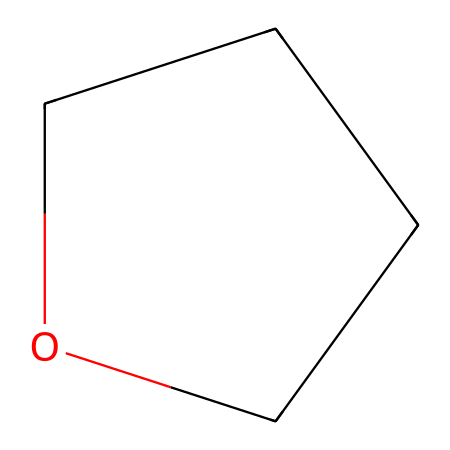What is the name of this chemical? The SMILES representation provided indicates the structure contains a five-membered ring including oxygen, which is characteristic of tetrahydrofuran (THF).
Answer: tetrahydrofuran How many carbons are in the structure? The SMILES notation shows two carbon atoms outside the ring and two within the ring, giving a total of four carbon atoms.
Answer: 4 What is the functional group present in this molecule? The molecule includes an ether group due to the presence of an oxygen atom bonded to two carbons, fulfilling the definition of ethers.
Answer: ether How many hydrogen atoms are connected to the carbon atoms in this molecule? Each carbon in tetrahydrofuran is bonded adequately to hydrogen atoms to satisfy the tetravalency of carbon, leading to a total of eight hydrogen atoms.
Answer: 8 What is the molecular formula of tetrahydrofuran? By counting the atoms represented in the SMILES, we deduce that there are four carbon atoms, eight hydrogen atoms, and one oxygen atom, leading to the formula C4H8O.
Answer: C4H8O What type of solvent is tetrahydrofuran typically used as? Tetrahydrofuran is commonly used as a solvent in pharmaceutical manufacturing due to its ability to dissolve a wide range of polar and nonpolar compounds.
Answer: aprotic solvent How does the structure of tetrahydrofuran affect its boiling point compared to linear ethers? The ring structure in tetrahydrofuran imposes more strain compared to linear ethers, resulting in a lower boiling point than some linear ethers with an equivalent number of carbons.
Answer: lower boiling point 